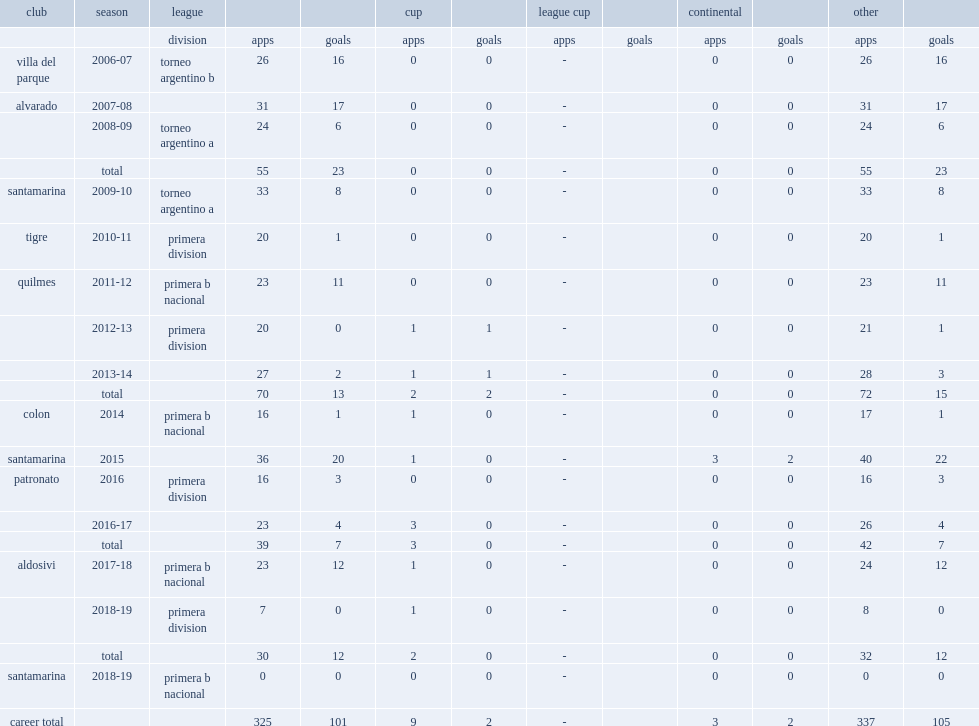How many league goals did telechea score for colon in 2014? 1.0. Write the full table. {'header': ['club', 'season', 'league', '', '', 'cup', '', 'league cup', '', 'continental', '', 'other', ''], 'rows': [['', '', 'division', 'apps', 'goals', 'apps', 'goals', 'apps', 'goals', 'apps', 'goals', 'apps', 'goals'], ['villa del parque', '2006-07', 'torneo argentino b', '26', '16', '0', '0', '-', '', '0', '0', '26', '16'], ['alvarado', '2007-08', '', '31', '17', '0', '0', '-', '', '0', '0', '31', '17'], ['', '2008-09', 'torneo argentino a', '24', '6', '0', '0', '-', '', '0', '0', '24', '6'], ['', 'total', '', '55', '23', '0', '0', '-', '', '0', '0', '55', '23'], ['santamarina', '2009-10', 'torneo argentino a', '33', '8', '0', '0', '-', '', '0', '0', '33', '8'], ['tigre', '2010-11', 'primera division', '20', '1', '0', '0', '-', '', '0', '0', '20', '1'], ['quilmes', '2011-12', 'primera b nacional', '23', '11', '0', '0', '-', '', '0', '0', '23', '11'], ['', '2012-13', 'primera division', '20', '0', '1', '1', '-', '', '0', '0', '21', '1'], ['', '2013-14', '', '27', '2', '1', '1', '-', '', '0', '0', '28', '3'], ['', 'total', '', '70', '13', '2', '2', '-', '', '0', '0', '72', '15'], ['colon', '2014', 'primera b nacional', '16', '1', '1', '0', '-', '', '0', '0', '17', '1'], ['santamarina', '2015', '', '36', '20', '1', '0', '-', '', '3', '2', '40', '22'], ['patronato', '2016', 'primera division', '16', '3', '0', '0', '-', '', '0', '0', '16', '3'], ['', '2016-17', '', '23', '4', '3', '0', '-', '', '0', '0', '26', '4'], ['', 'total', '', '39', '7', '3', '0', '-', '', '0', '0', '42', '7'], ['aldosivi', '2017-18', 'primera b nacional', '23', '12', '1', '0', '-', '', '0', '0', '24', '12'], ['', '2018-19', 'primera division', '7', '0', '1', '0', '-', '', '0', '0', '8', '0'], ['', 'total', '', '30', '12', '2', '0', '-', '', '0', '0', '32', '12'], ['santamarina', '2018-19', 'primera b nacional', '0', '0', '0', '0', '-', '', '0', '0', '0', '0'], ['career total', '', '', '325', '101', '9', '2', '-', '', '3', '2', '337', '105']]} 